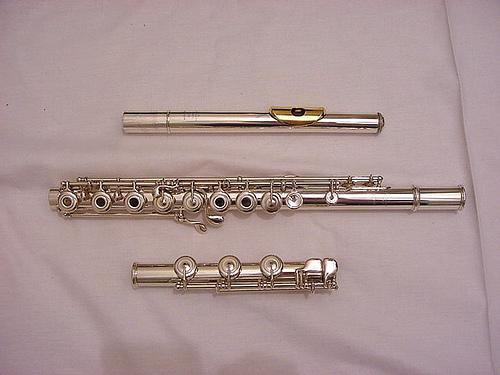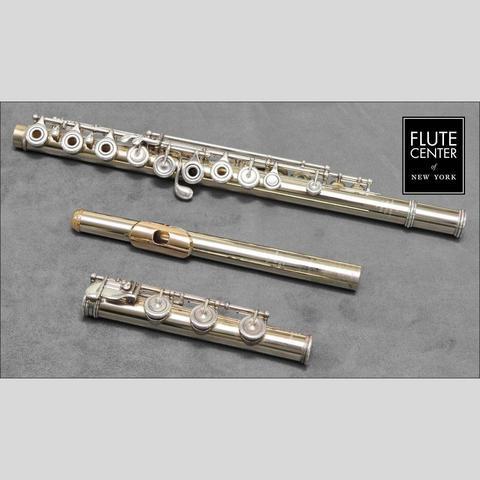The first image is the image on the left, the second image is the image on the right. Assess this claim about the two images: "Exactly two mouthpieces are visible.". Correct or not? Answer yes or no. Yes. 